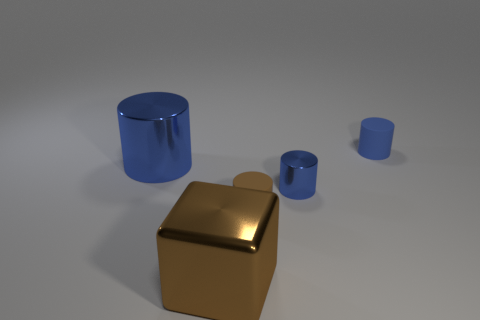Subtract all blue cylinders. How many were subtracted if there are1blue cylinders left? 2 Subtract all purple blocks. How many blue cylinders are left? 3 Subtract 1 cylinders. How many cylinders are left? 3 Add 3 green spheres. How many objects exist? 8 Subtract all cubes. How many objects are left? 4 Subtract all cylinders. Subtract all gray cubes. How many objects are left? 1 Add 1 small blue rubber objects. How many small blue rubber objects are left? 2 Add 2 large blue cylinders. How many large blue cylinders exist? 3 Subtract 0 yellow cylinders. How many objects are left? 5 